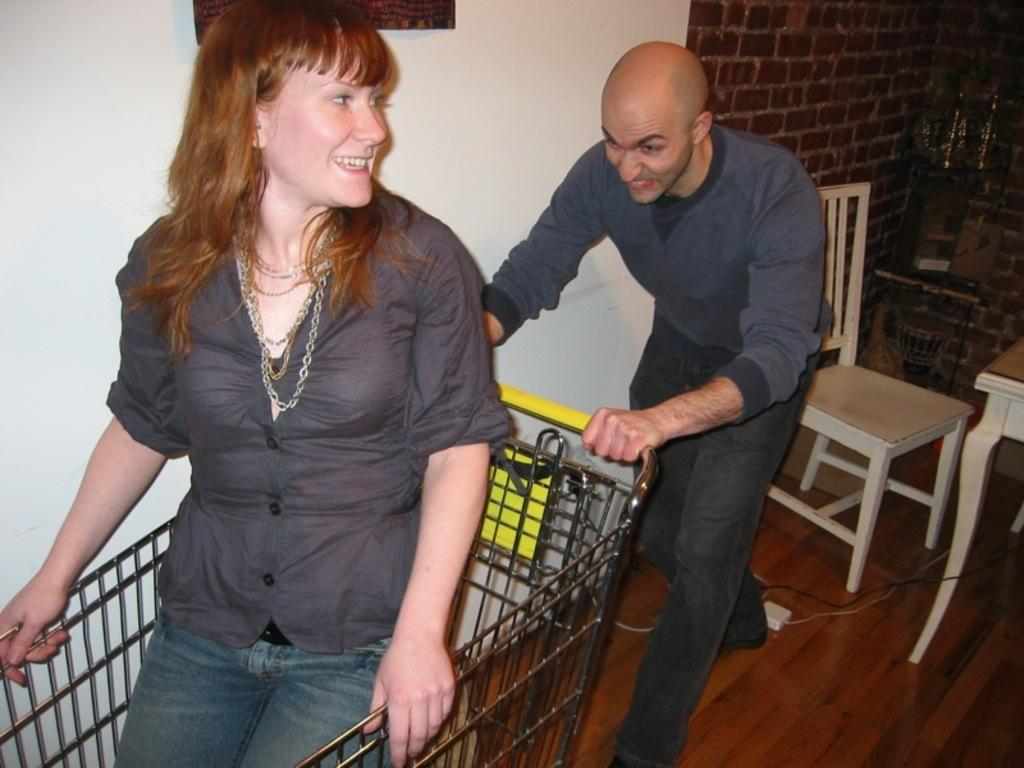What is the woman doing in the image? The woman is sitting in a trolley. Who is assisting the woman in the trolley? There is a man pushing the trolley. What type of furniture is present in the image? A hire table and hire chairs are present. How many children are sitting on the can in the image? There is no can or children present in the image. What route is the trolley taking in the image? The image does not provide information about the trolley's route. 